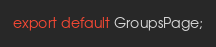Convert code to text. <code><loc_0><loc_0><loc_500><loc_500><_JavaScript_>export default GroupsPage;</code> 